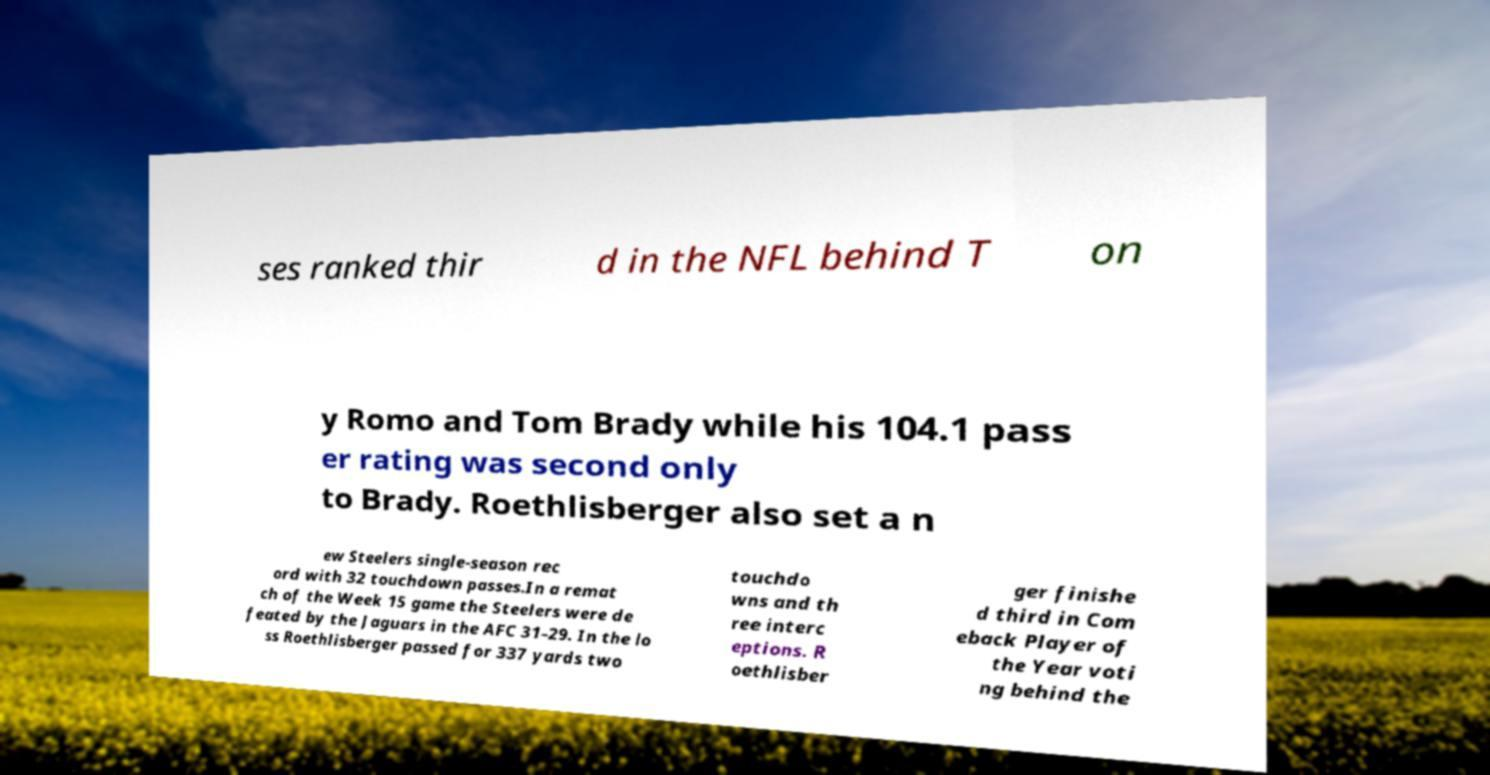Could you assist in decoding the text presented in this image and type it out clearly? ses ranked thir d in the NFL behind T on y Romo and Tom Brady while his 104.1 pass er rating was second only to Brady. Roethlisberger also set a n ew Steelers single-season rec ord with 32 touchdown passes.In a remat ch of the Week 15 game the Steelers were de feated by the Jaguars in the AFC 31–29. In the lo ss Roethlisberger passed for 337 yards two touchdo wns and th ree interc eptions. R oethlisber ger finishe d third in Com eback Player of the Year voti ng behind the 